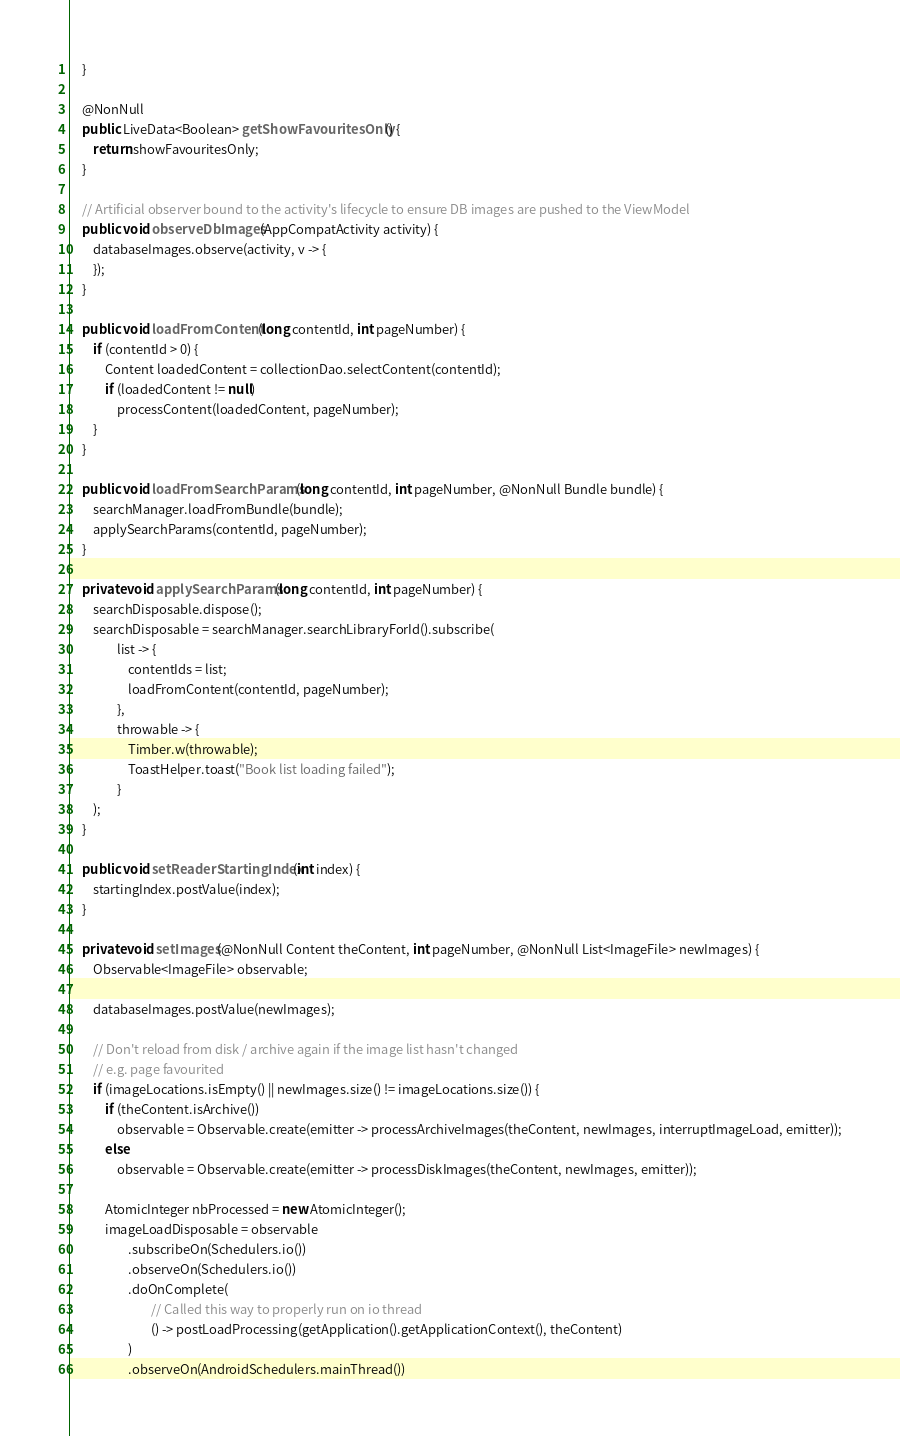Convert code to text. <code><loc_0><loc_0><loc_500><loc_500><_Java_>    }

    @NonNull
    public LiveData<Boolean> getShowFavouritesOnly() {
        return showFavouritesOnly;
    }

    // Artificial observer bound to the activity's lifecycle to ensure DB images are pushed to the ViewModel
    public void observeDbImages(AppCompatActivity activity) {
        databaseImages.observe(activity, v -> {
        });
    }

    public void loadFromContent(long contentId, int pageNumber) {
        if (contentId > 0) {
            Content loadedContent = collectionDao.selectContent(contentId);
            if (loadedContent != null)
                processContent(loadedContent, pageNumber);
        }
    }

    public void loadFromSearchParams(long contentId, int pageNumber, @NonNull Bundle bundle) {
        searchManager.loadFromBundle(bundle);
        applySearchParams(contentId, pageNumber);
    }

    private void applySearchParams(long contentId, int pageNumber) {
        searchDisposable.dispose();
        searchDisposable = searchManager.searchLibraryForId().subscribe(
                list -> {
                    contentIds = list;
                    loadFromContent(contentId, pageNumber);
                },
                throwable -> {
                    Timber.w(throwable);
                    ToastHelper.toast("Book list loading failed");
                }
        );
    }

    public void setReaderStartingIndex(int index) {
        startingIndex.postValue(index);
    }

    private void setImages(@NonNull Content theContent, int pageNumber, @NonNull List<ImageFile> newImages) {
        Observable<ImageFile> observable;

        databaseImages.postValue(newImages);

        // Don't reload from disk / archive again if the image list hasn't changed
        // e.g. page favourited
        if (imageLocations.isEmpty() || newImages.size() != imageLocations.size()) {
            if (theContent.isArchive())
                observable = Observable.create(emitter -> processArchiveImages(theContent, newImages, interruptImageLoad, emitter));
            else
                observable = Observable.create(emitter -> processDiskImages(theContent, newImages, emitter));

            AtomicInteger nbProcessed = new AtomicInteger();
            imageLoadDisposable = observable
                    .subscribeOn(Schedulers.io())
                    .observeOn(Schedulers.io())
                    .doOnComplete(
                            // Called this way to properly run on io thread
                            () -> postLoadProcessing(getApplication().getApplicationContext(), theContent)
                    )
                    .observeOn(AndroidSchedulers.mainThread())</code> 